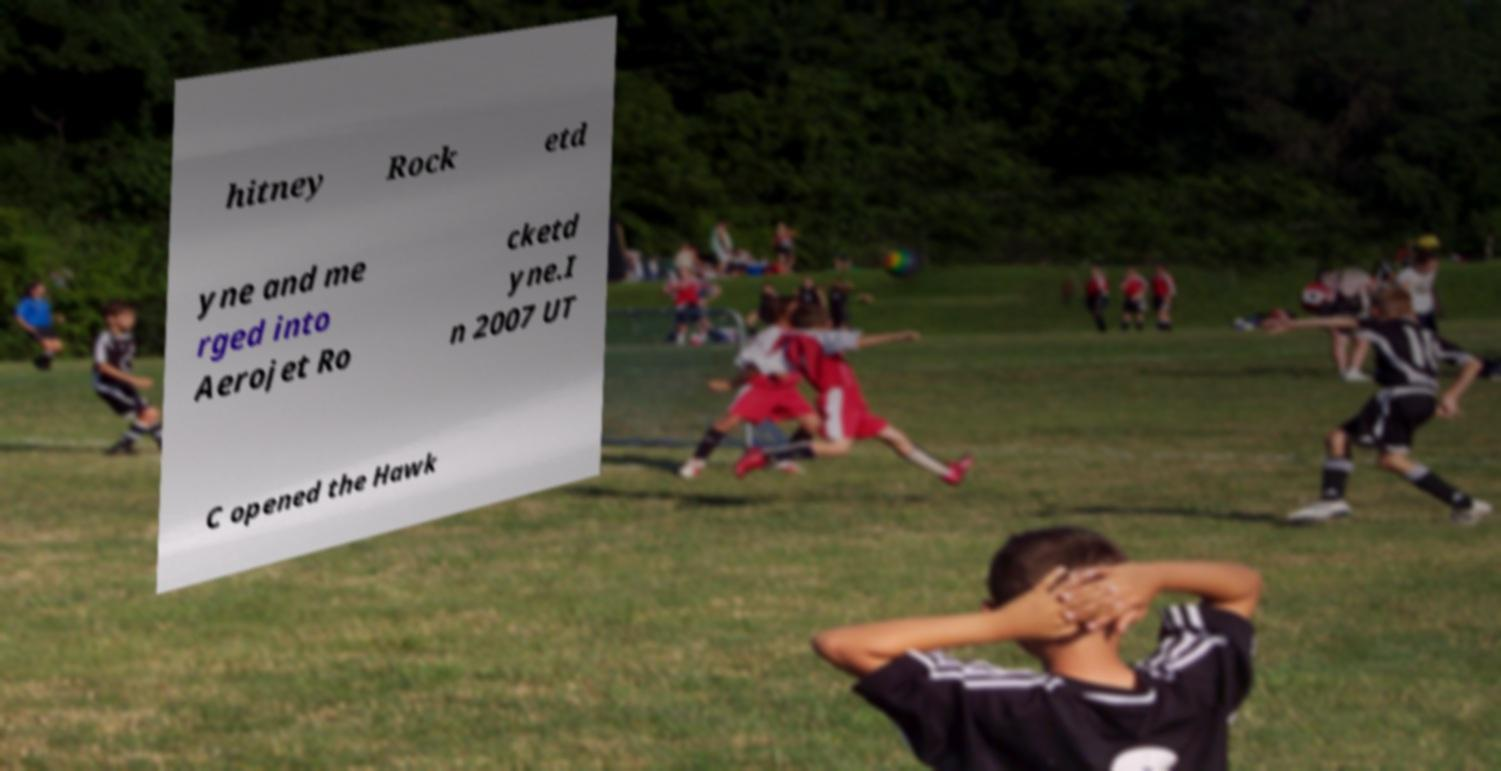For documentation purposes, I need the text within this image transcribed. Could you provide that? hitney Rock etd yne and me rged into Aerojet Ro cketd yne.I n 2007 UT C opened the Hawk 